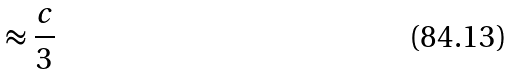Convert formula to latex. <formula><loc_0><loc_0><loc_500><loc_500>\approx \frac { c } { 3 }</formula> 